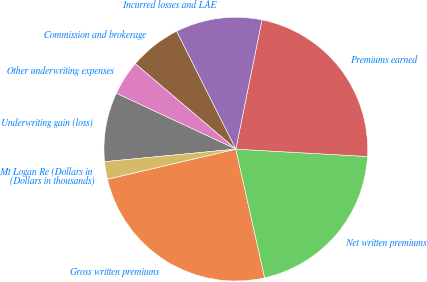Convert chart to OTSL. <chart><loc_0><loc_0><loc_500><loc_500><pie_chart><fcel>(Dollars in thousands)<fcel>Gross written premiums<fcel>Net written premiums<fcel>Premiums earned<fcel>Incurred losses and LAE<fcel>Commission and brokerage<fcel>Other underwriting expenses<fcel>Underwriting gain (loss)<fcel>Mt Logan Re (Dollars in<nl><fcel>0.02%<fcel>24.83%<fcel>20.6%<fcel>22.71%<fcel>10.6%<fcel>6.37%<fcel>4.25%<fcel>8.48%<fcel>2.14%<nl></chart> 